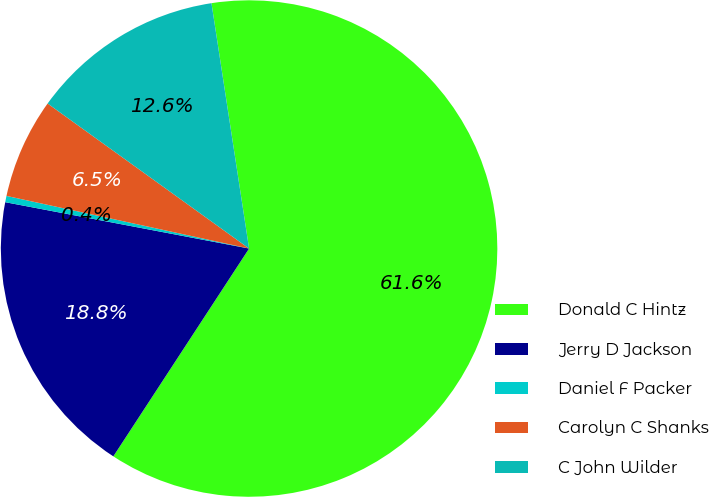Convert chart to OTSL. <chart><loc_0><loc_0><loc_500><loc_500><pie_chart><fcel>Donald C Hintz<fcel>Jerry D Jackson<fcel>Daniel F Packer<fcel>Carolyn C Shanks<fcel>C John Wilder<nl><fcel>61.63%<fcel>18.78%<fcel>0.41%<fcel>6.53%<fcel>12.65%<nl></chart> 